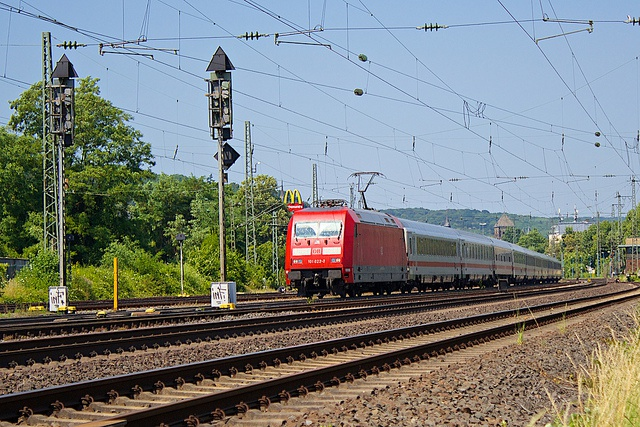Describe the objects in this image and their specific colors. I can see train in darkgray, gray, black, and maroon tones and traffic light in darkgray, black, gray, and navy tones in this image. 